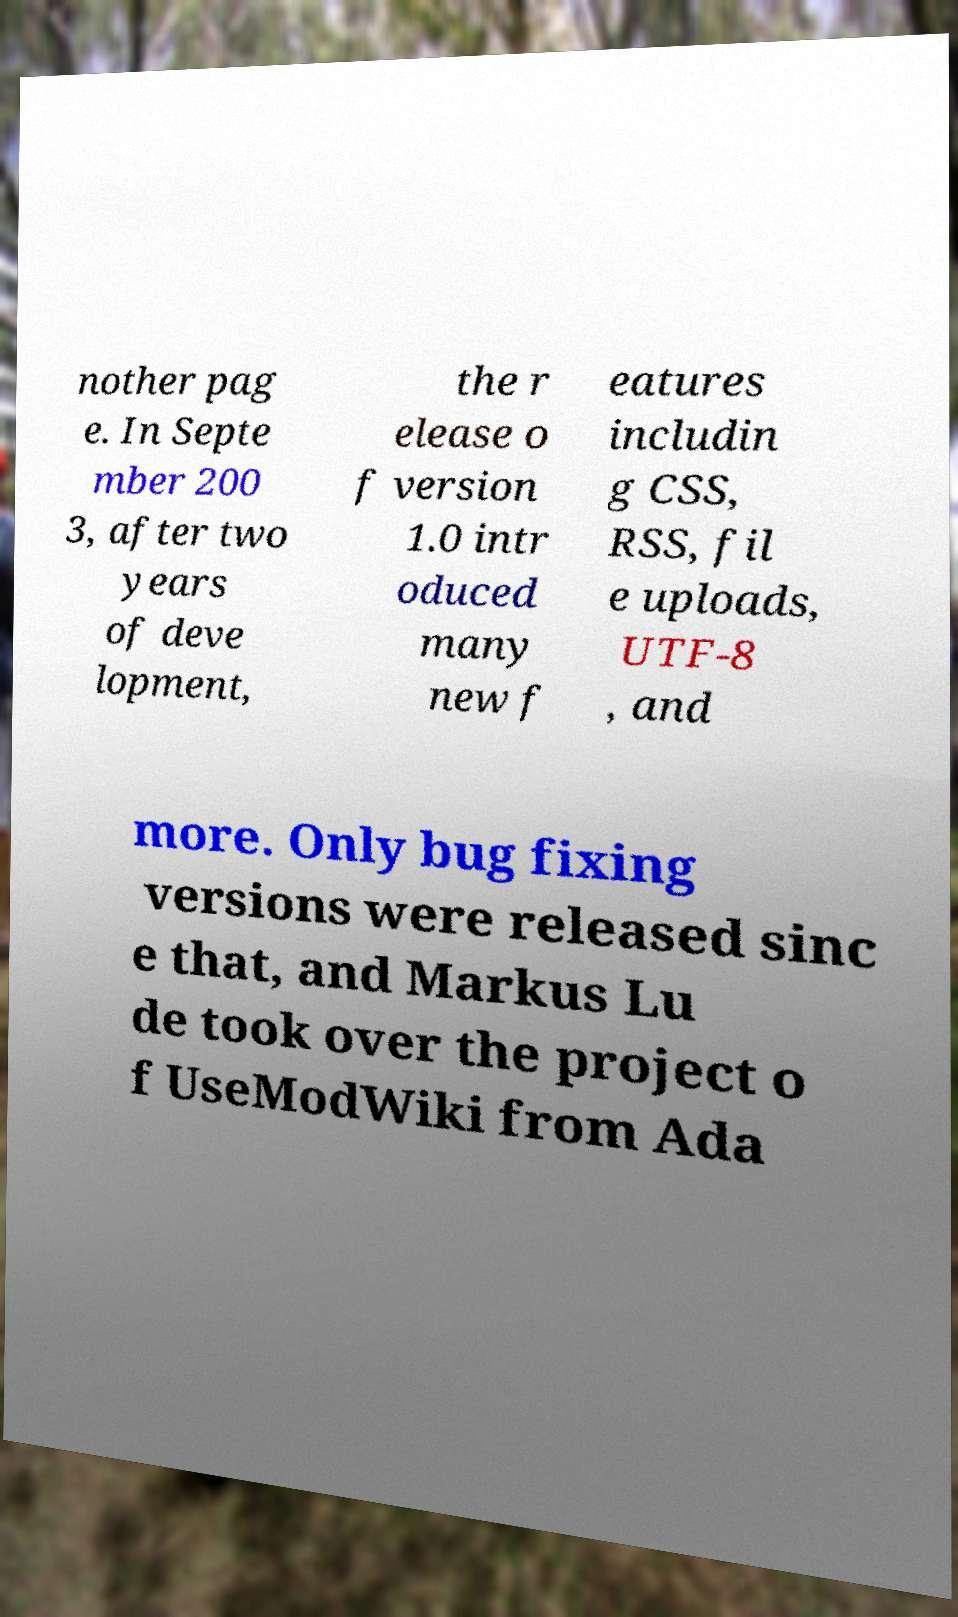There's text embedded in this image that I need extracted. Can you transcribe it verbatim? nother pag e. In Septe mber 200 3, after two years of deve lopment, the r elease o f version 1.0 intr oduced many new f eatures includin g CSS, RSS, fil e uploads, UTF-8 , and more. Only bug fixing versions were released sinc e that, and Markus Lu de took over the project o f UseModWiki from Ada 